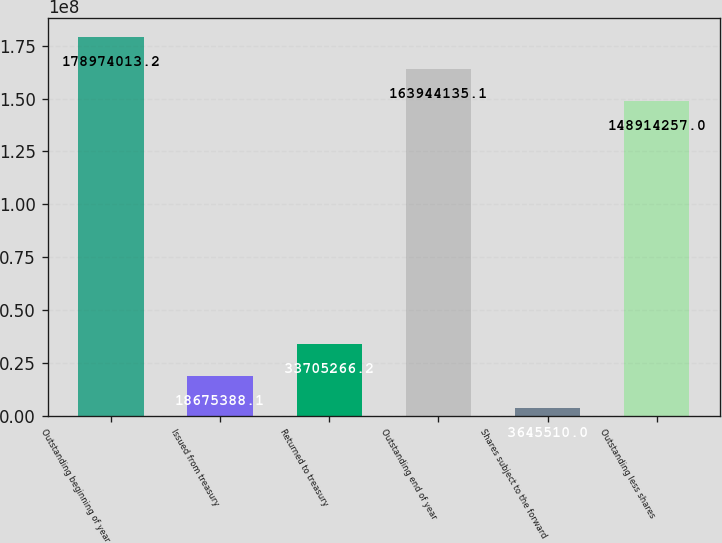Convert chart. <chart><loc_0><loc_0><loc_500><loc_500><bar_chart><fcel>Outstanding beginning of year<fcel>Issued from treasury<fcel>Returned to treasury<fcel>Outstanding end of year<fcel>Shares subject to the forward<fcel>Outstanding less shares<nl><fcel>1.78974e+08<fcel>1.86754e+07<fcel>3.37053e+07<fcel>1.63944e+08<fcel>3.64551e+06<fcel>1.48914e+08<nl></chart> 